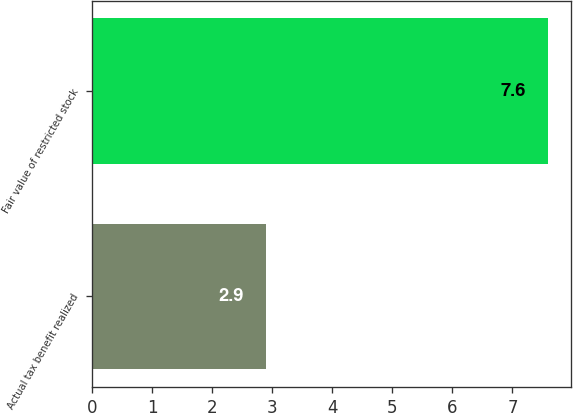Convert chart to OTSL. <chart><loc_0><loc_0><loc_500><loc_500><bar_chart><fcel>Actual tax benefit realized<fcel>Fair value of restricted stock<nl><fcel>2.9<fcel>7.6<nl></chart> 